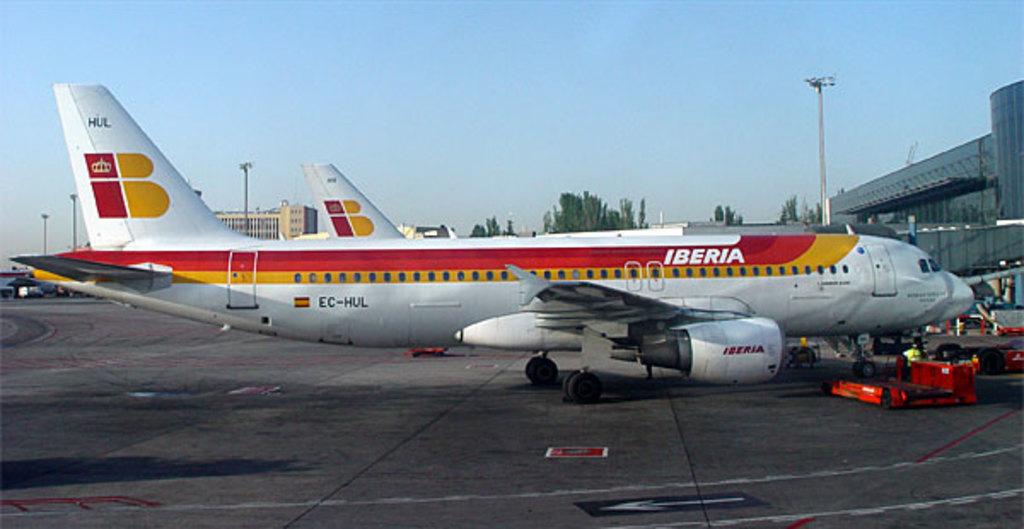What is the name on the plane?
Make the answer very short. Iberia. What is the model number of the plane printed on the rear?
Your response must be concise. Ec-hul. 